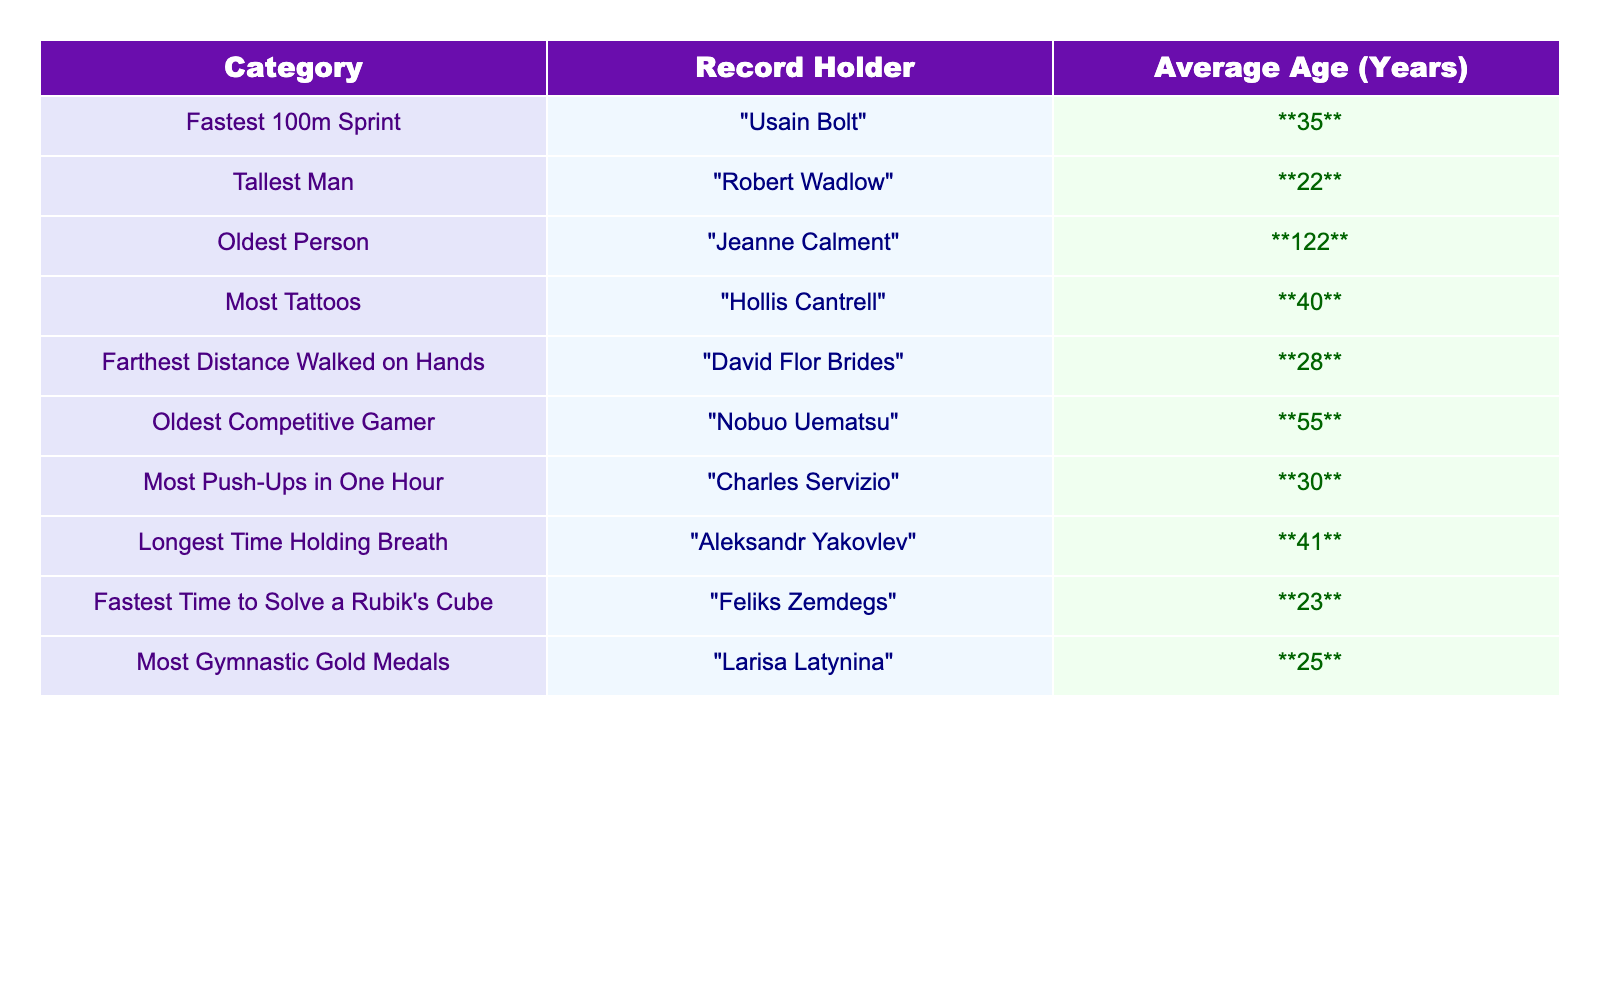What is the average age of the fastest 100m sprint record holder? The table shows that Usain Bolt holds the record for the fastest 100m sprint with an average age of 35 years.
Answer: 35 Who holds the record for the oldest person, and what is their average age? According to the table, Jeanne Calment holds the record for the oldest person with an average age of 122 years.
Answer: Jeanne Calment, 122 What is the average age of record holders in the "Most Tattoos" category? The data shows Hollis Cantrell holds the record for "Most Tattoos" with an average age of 40 years.
Answer: 40 What is the age difference between the oldest competitive gamer and the tallest man? Nobuo Uematsu, the oldest competitive gamer, is 55 years old, while Robert Wadlow, the tallest man, is 22 years old. The difference is 55 - 22 = 33 years.
Answer: 33 Which record holder has the lowest average age, and what is that age? The table shows Robert Wadlow, the tallest man, has the lowest average age at 22 years.
Answer: 22 What is the average age of record holders in the categories of "Most Push-Ups in One Hour" and "Farthest Distance Walked on Hands"? The average age for "Most Push-Ups in One Hour" is 30 years, and for "Farthest Distance Walked on Hands," it is 28 years. The average of these two ages is (30 + 28) / 2 = 29 years.
Answer: 29 Is the average age of record holders for the "Fastest Time to Solve a Rubik's Cube" greater than that of the "Most Gymnastic Gold Medals"? Feliks Zemdegs, the holder for the fastest Rubik's Cube time, is 23 years old, while Larisa Latynina for gymnastics is 25 years old. Since 23 is less than 25, the statement is false.
Answer: No What is the combined average age of record holders in the "Oldest Competitive Gamer" and "Longest Time Holding Breath" categories? Nobuo Uematsu, the oldest competitive gamer, is 55 years old, and Aleksandr Yakovlev, for the longest time holding breath, is 41 years old. The combined average is (55 + 41) / 2 = 48 years.
Answer: 48 Which two records have an average age greater than 40, and what are their ages? According to the table, the records for "Oldest Competitive Gamer" (55 years) and "Longest Time Holding Breath" (41 years) both exceed an average age of 40 years.
Answer: 55 and 41 What is the age range among all record holders listed in the table? The oldest record holder is Jeanne Calment at 122 years, and the youngest is Robert Wadlow at 22 years. The age range is therefore 122 - 22 = 100 years.
Answer: 100 